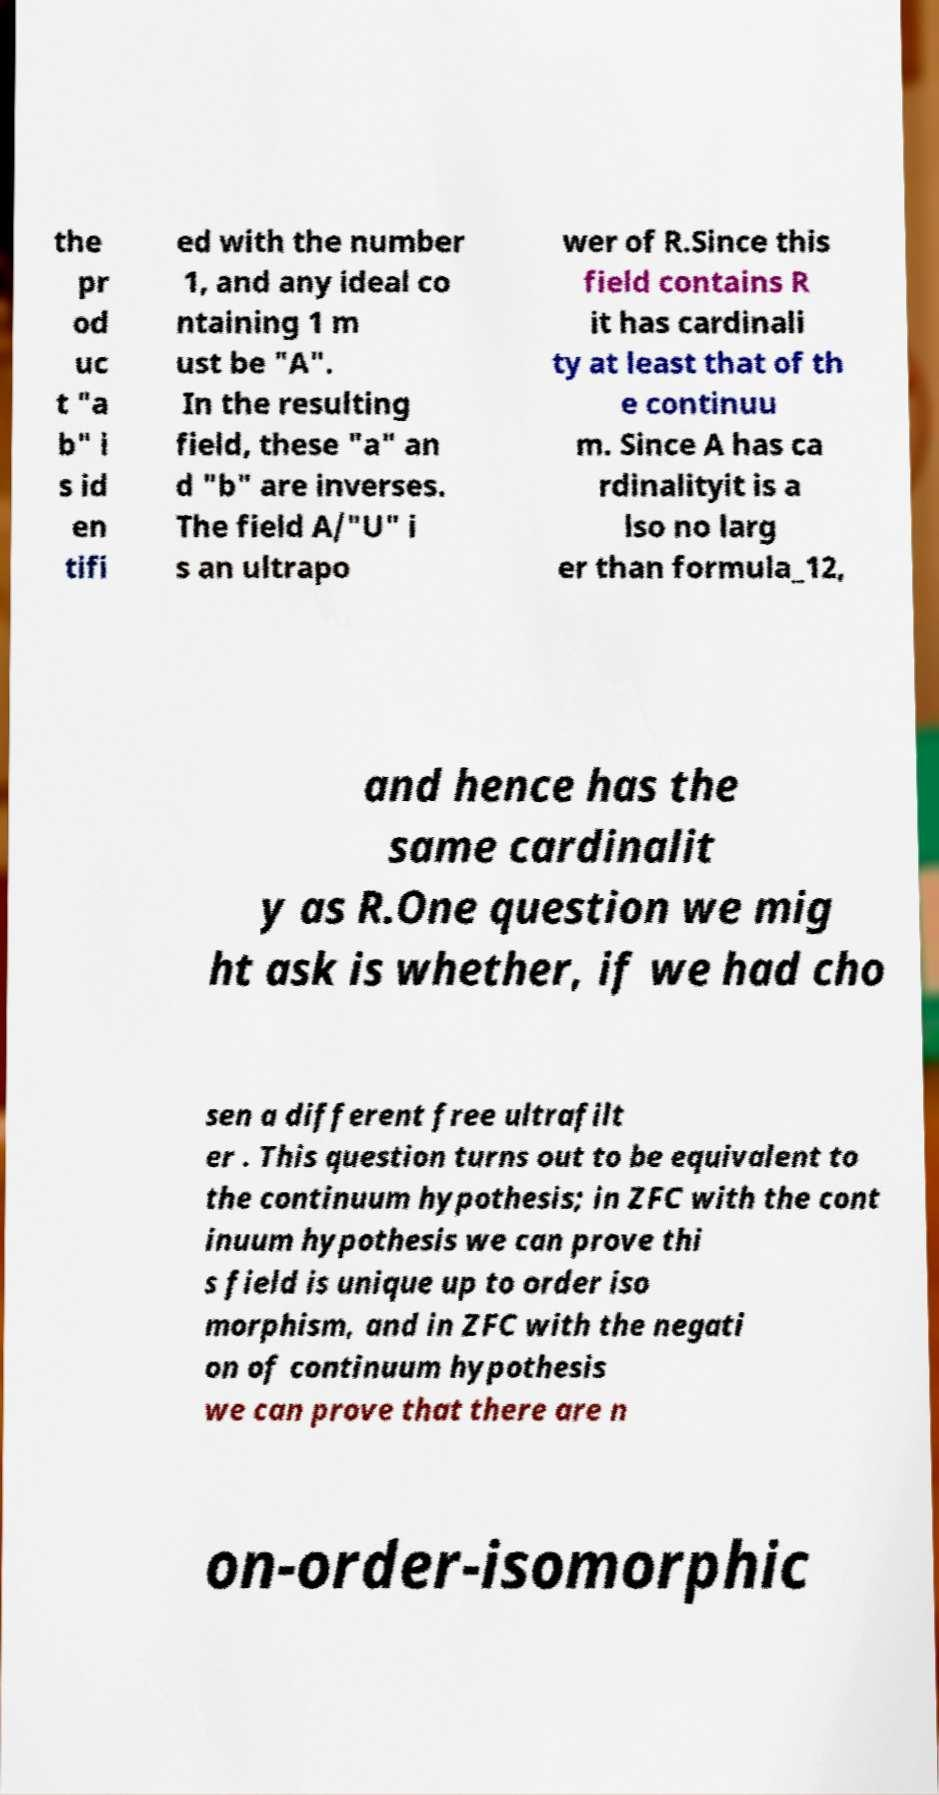There's text embedded in this image that I need extracted. Can you transcribe it verbatim? the pr od uc t "a b" i s id en tifi ed with the number 1, and any ideal co ntaining 1 m ust be "A". In the resulting field, these "a" an d "b" are inverses. The field A/"U" i s an ultrapo wer of R.Since this field contains R it has cardinali ty at least that of th e continuu m. Since A has ca rdinalityit is a lso no larg er than formula_12, and hence has the same cardinalit y as R.One question we mig ht ask is whether, if we had cho sen a different free ultrafilt er . This question turns out to be equivalent to the continuum hypothesis; in ZFC with the cont inuum hypothesis we can prove thi s field is unique up to order iso morphism, and in ZFC with the negati on of continuum hypothesis we can prove that there are n on-order-isomorphic 